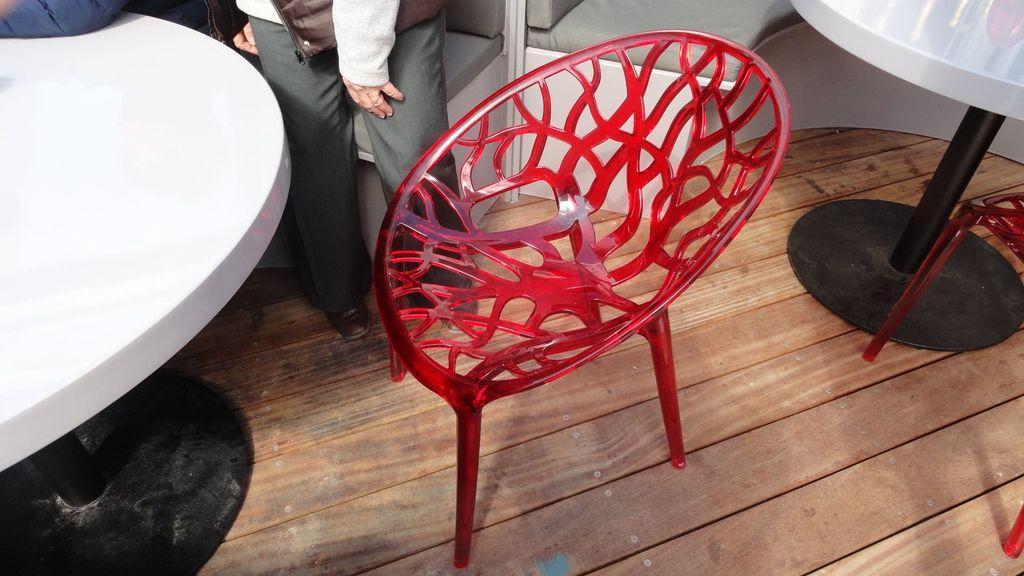Describe this image in one or two sentences. In the image there are chairs and table on the wooden floor with two persons standing in the back. 